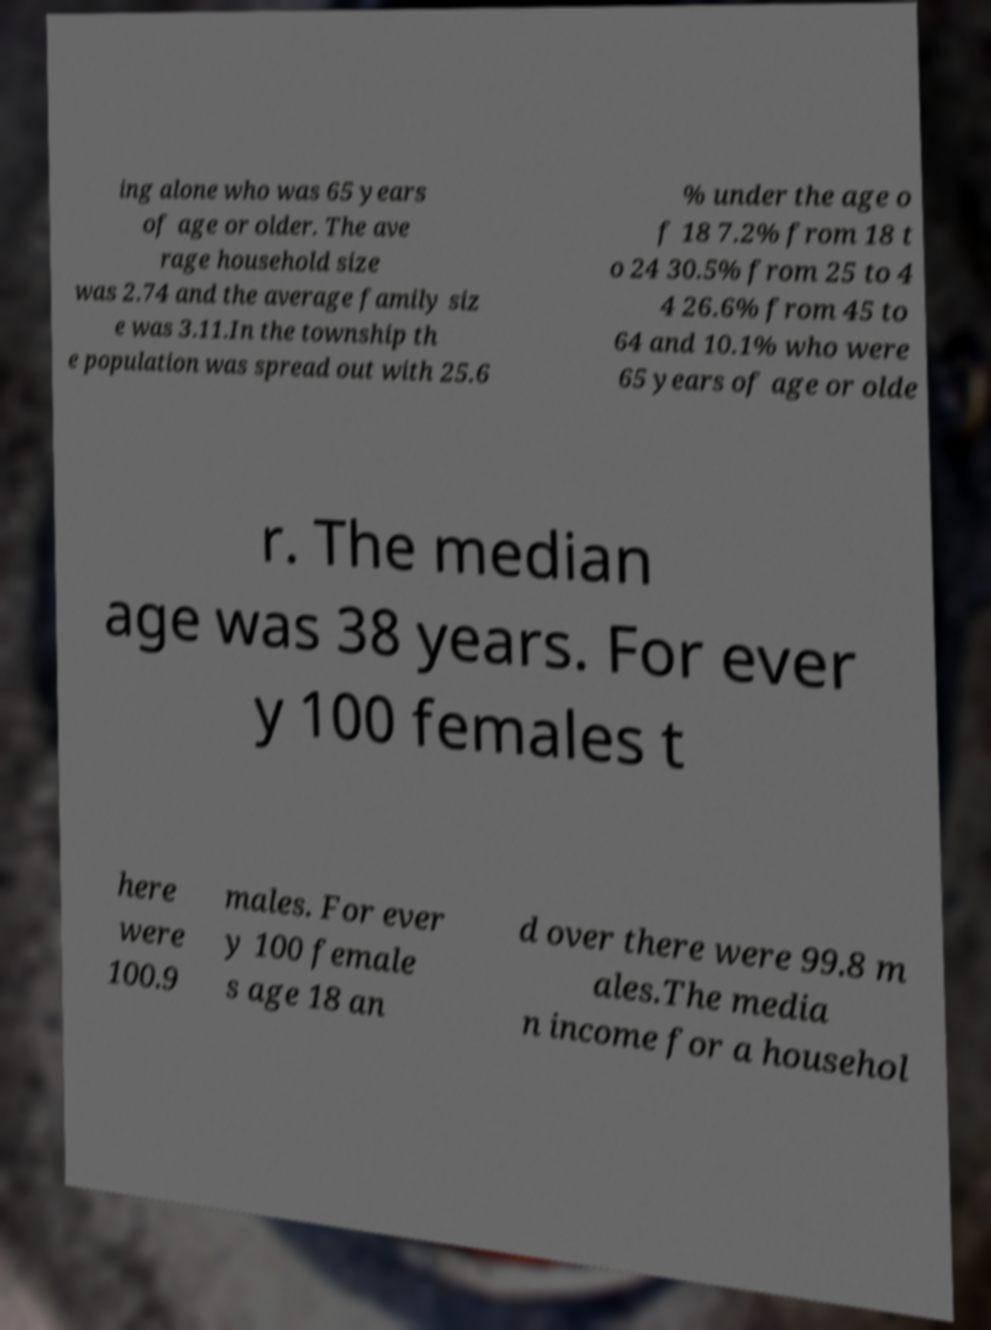Could you assist in decoding the text presented in this image and type it out clearly? ing alone who was 65 years of age or older. The ave rage household size was 2.74 and the average family siz e was 3.11.In the township th e population was spread out with 25.6 % under the age o f 18 7.2% from 18 t o 24 30.5% from 25 to 4 4 26.6% from 45 to 64 and 10.1% who were 65 years of age or olde r. The median age was 38 years. For ever y 100 females t here were 100.9 males. For ever y 100 female s age 18 an d over there were 99.8 m ales.The media n income for a househol 